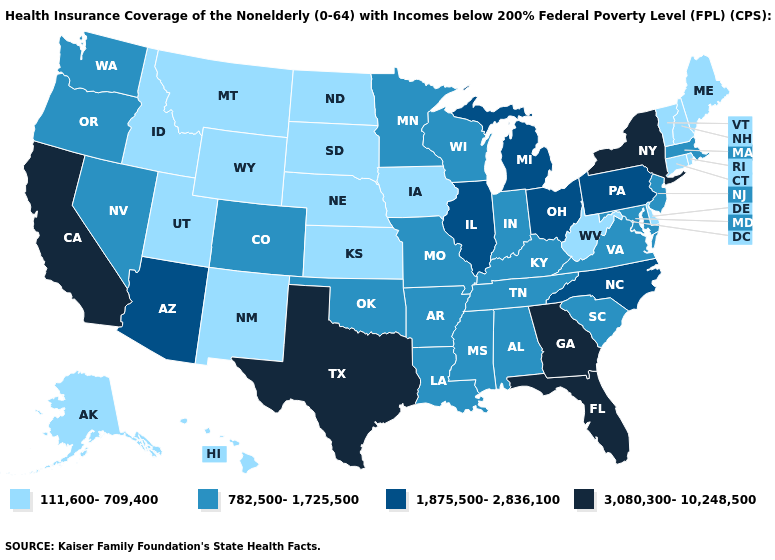What is the value of California?
Be succinct. 3,080,300-10,248,500. Which states have the lowest value in the USA?
Keep it brief. Alaska, Connecticut, Delaware, Hawaii, Idaho, Iowa, Kansas, Maine, Montana, Nebraska, New Hampshire, New Mexico, North Dakota, Rhode Island, South Dakota, Utah, Vermont, West Virginia, Wyoming. What is the value of Idaho?
Keep it brief. 111,600-709,400. Name the states that have a value in the range 1,875,500-2,836,100?
Write a very short answer. Arizona, Illinois, Michigan, North Carolina, Ohio, Pennsylvania. Does Arizona have a higher value than Pennsylvania?
Be succinct. No. Does the map have missing data?
Write a very short answer. No. What is the highest value in the Northeast ?
Quick response, please. 3,080,300-10,248,500. How many symbols are there in the legend?
Quick response, please. 4. What is the value of Tennessee?
Short answer required. 782,500-1,725,500. What is the value of Missouri?
Short answer required. 782,500-1,725,500. Among the states that border Wyoming , does South Dakota have the highest value?
Give a very brief answer. No. Which states have the lowest value in the USA?
Answer briefly. Alaska, Connecticut, Delaware, Hawaii, Idaho, Iowa, Kansas, Maine, Montana, Nebraska, New Hampshire, New Mexico, North Dakota, Rhode Island, South Dakota, Utah, Vermont, West Virginia, Wyoming. Does Georgia have the highest value in the USA?
Be succinct. Yes. What is the lowest value in the USA?
Answer briefly. 111,600-709,400. What is the value of Kentucky?
Answer briefly. 782,500-1,725,500. 